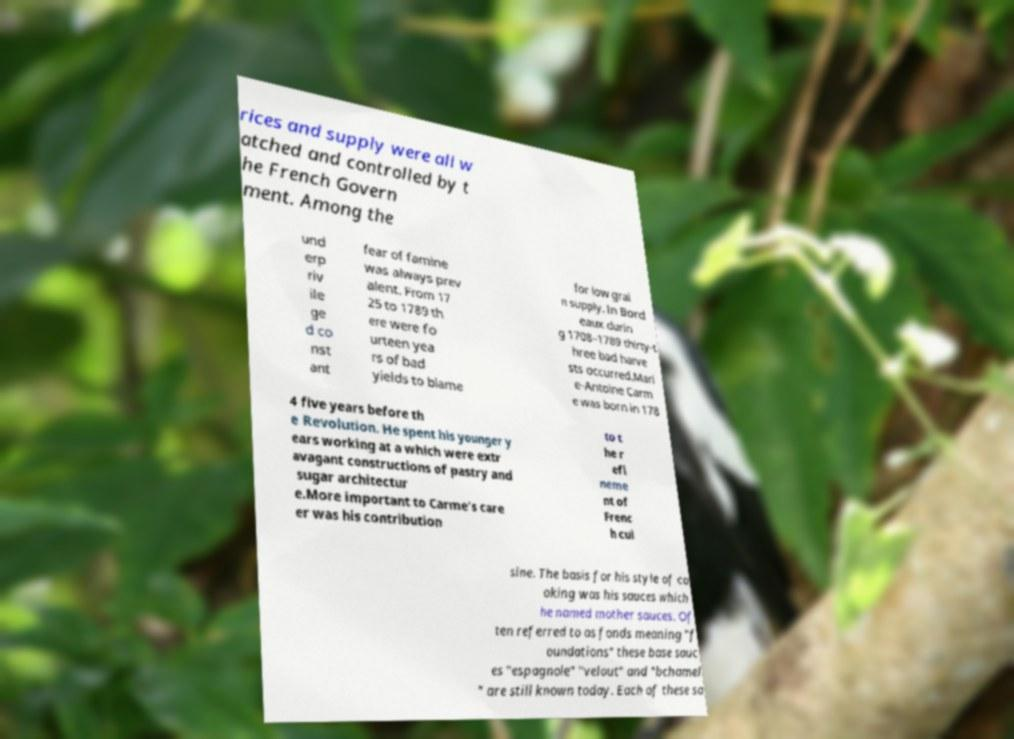What messages or text are displayed in this image? I need them in a readable, typed format. rices and supply were all w atched and controlled by t he French Govern ment. Among the und erp riv ile ge d co nst ant fear of famine was always prev alent. From 17 25 to 1789 th ere were fo urteen yea rs of bad yields to blame for low grai n supply. In Bord eaux durin g 1708–1789 thirty-t hree bad harve sts occurred.Mari e-Antoine Carm e was born in 178 4 five years before th e Revolution. He spent his younger y ears working at a which were extr avagant constructions of pastry and sugar architectur e.More important to Carme's care er was his contribution to t he r efi neme nt of Frenc h cui sine. The basis for his style of co oking was his sauces which he named mother sauces. Of ten referred to as fonds meaning "f oundations" these base sauc es "espagnole" "velout" and "bchamel " are still known today. Each of these sa 